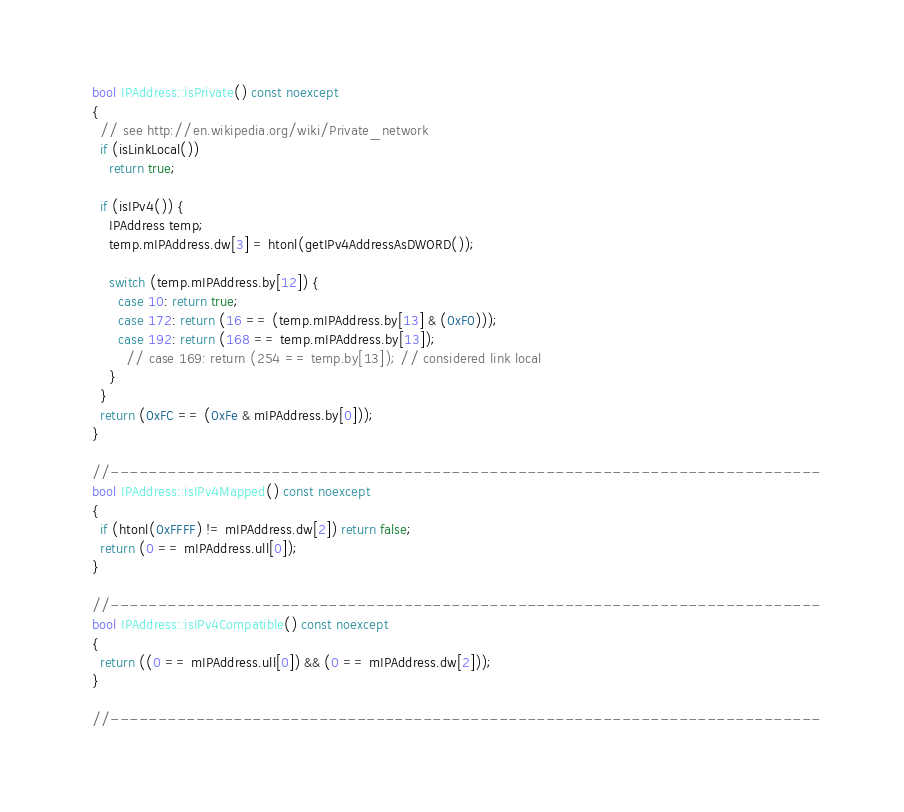<code> <loc_0><loc_0><loc_500><loc_500><_C++_>  bool IPAddress::isPrivate() const noexcept
  {
    // see http://en.wikipedia.org/wiki/Private_network
    if (isLinkLocal())
      return true;

    if (isIPv4()) {
      IPAddress temp;
      temp.mIPAddress.dw[3] = htonl(getIPv4AddressAsDWORD());

      switch (temp.mIPAddress.by[12]) {
        case 10: return true;
        case 172: return (16 == (temp.mIPAddress.by[13] & (0xF0)));
        case 192: return (168 == temp.mIPAddress.by[13]);
          // case 169: return (254 == temp.by[13]); // considered link local
      }
    }
    return (0xFC == (0xFe & mIPAddress.by[0]));
  }

  //---------------------------------------------------------------------------
  bool IPAddress::isIPv4Mapped() const noexcept
  {
    if (htonl(0xFFFF) != mIPAddress.dw[2]) return false;
    return (0 == mIPAddress.ull[0]);
  }

  //---------------------------------------------------------------------------
  bool IPAddress::isIPv4Compatible() const noexcept
  {
    return ((0 == mIPAddress.ull[0]) && (0 == mIPAddress.dw[2]));
  }

  //---------------------------------------------------------------------------</code> 